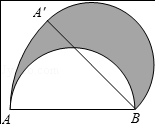First perform reasoning, then finally select the question from the choices in the following format: Answer: xxx.
Question: In the given figure, if a semicircle with AB as its diameter and a length of 4.0 units rotates clockwise about point B by 45.0 degrees, causing point A to move to position A′, what is the area of the shaded region?
Choices:
A: π
B: 2π
C: \frac{π}{2}
D: 4π Solution: Since S_shadow = S_sector ABA' + S_half_circle - S_half_circle = S_sector ABA' = frac {45\cdotπ\cdot4^{2}}{360} = 2π. Therefore, the answer is B.
Answer:B 